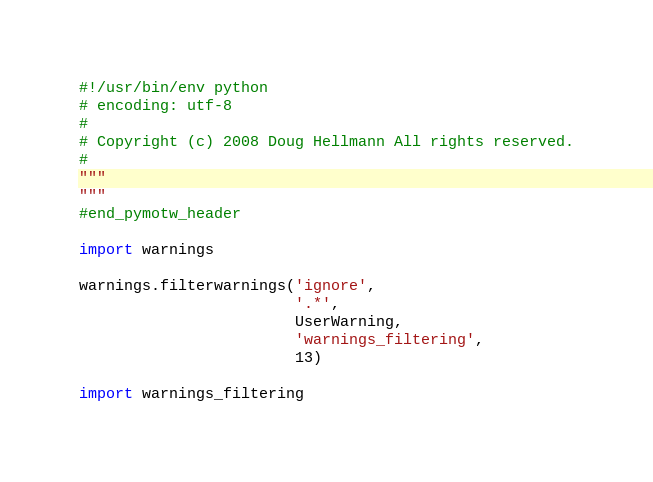<code> <loc_0><loc_0><loc_500><loc_500><_Python_>#!/usr/bin/env python
# encoding: utf-8
#
# Copyright (c) 2008 Doug Hellmann All rights reserved.
#
"""
"""
#end_pymotw_header

import warnings

warnings.filterwarnings('ignore', 
                        '.*', 
                        UserWarning,
                        'warnings_filtering',
                        13)

import warnings_filtering
</code> 